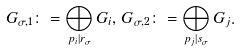Convert formula to latex. <formula><loc_0><loc_0><loc_500><loc_500>G _ { \sigma , 1 } \colon = \bigoplus _ { p _ { i } | r _ { \sigma } } G _ { i } , \, G _ { \sigma , 2 } \colon = \bigoplus _ { p _ { j } | s _ { \sigma } } G _ { j } .</formula> 